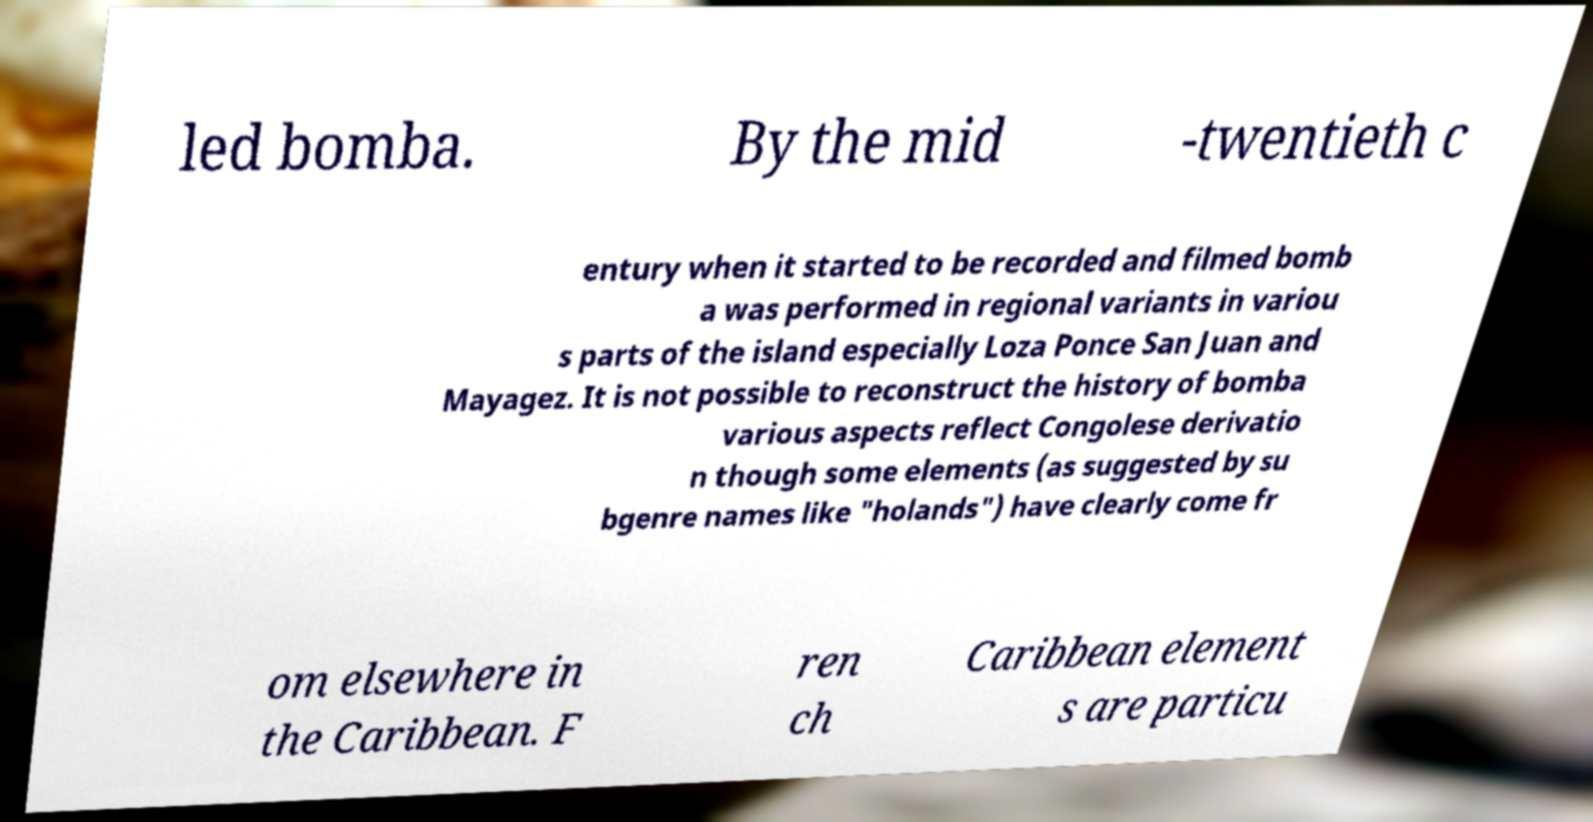Can you accurately transcribe the text from the provided image for me? led bomba. By the mid -twentieth c entury when it started to be recorded and filmed bomb a was performed in regional variants in variou s parts of the island especially Loza Ponce San Juan and Mayagez. It is not possible to reconstruct the history of bomba various aspects reflect Congolese derivatio n though some elements (as suggested by su bgenre names like "holands") have clearly come fr om elsewhere in the Caribbean. F ren ch Caribbean element s are particu 